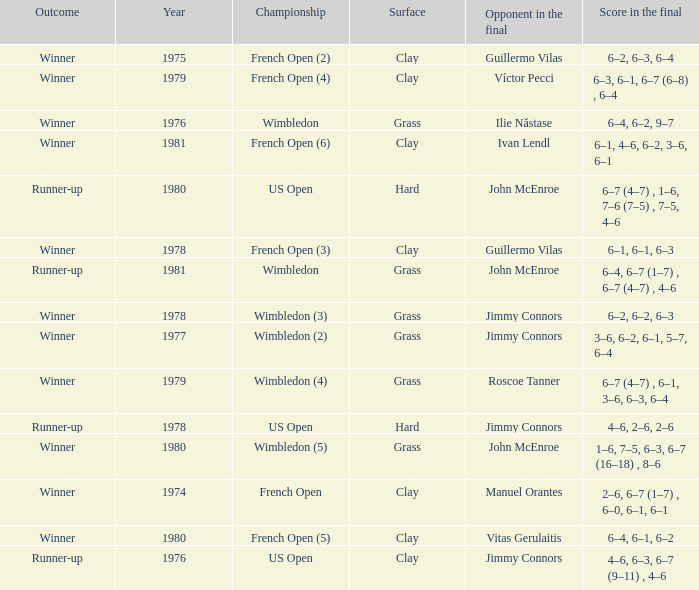What is every surface with a score in the final of 6–4, 6–7 (1–7) , 6–7 (4–7) , 4–6? Grass. 